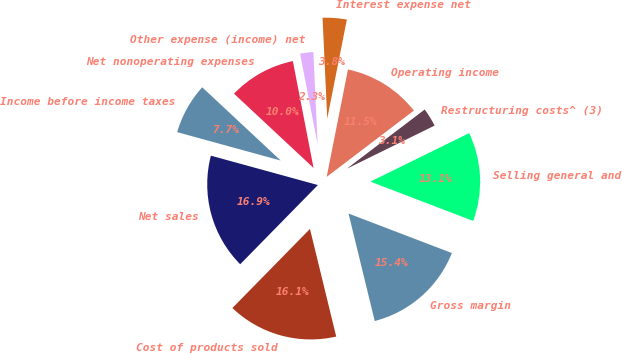<chart> <loc_0><loc_0><loc_500><loc_500><pie_chart><fcel>Net sales<fcel>Cost of products sold<fcel>Gross margin<fcel>Selling general and<fcel>Restructuring costs^ (3)<fcel>Operating income<fcel>Interest expense net<fcel>Other expense (income) net<fcel>Net nonoperating expenses<fcel>Income before income taxes<nl><fcel>16.92%<fcel>16.15%<fcel>15.38%<fcel>13.08%<fcel>3.08%<fcel>11.54%<fcel>3.85%<fcel>2.31%<fcel>10.0%<fcel>7.69%<nl></chart> 